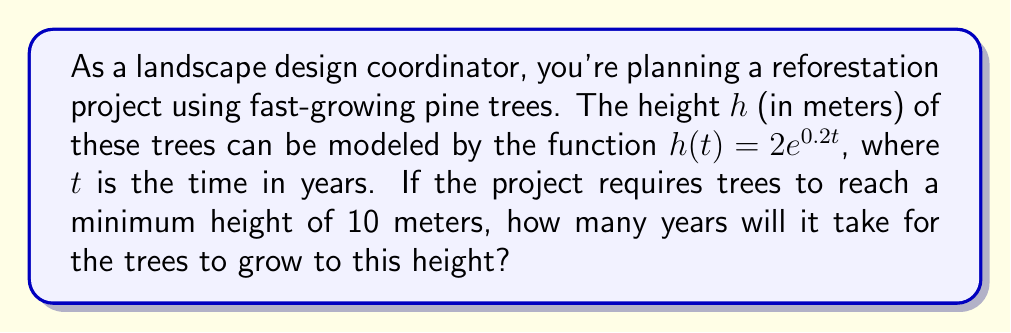Teach me how to tackle this problem. Let's approach this step-by-step:

1) We're given the growth model: $h(t) = 2e^{0.2t}$

2) We need to find $t$ when $h(t) = 10$ meters:

   $10 = 2e^{0.2t}$

3) Divide both sides by 2:

   $5 = e^{0.2t}$

4) Take the natural logarithm of both sides:

   $\ln(5) = \ln(e^{0.2t})$

5) Using the logarithm property $\ln(e^x) = x$:

   $\ln(5) = 0.2t$

6) Solve for $t$:

   $t = \frac{\ln(5)}{0.2}$

7) Calculate the result:

   $t = \frac{\ln(5)}{0.2} \approx 8.047$ years

8) Since we can't plant partial years, we round up to the nearest whole year.

Therefore, it will take 9 years for the trees to grow to a height of 10 meters.
Answer: 9 years 